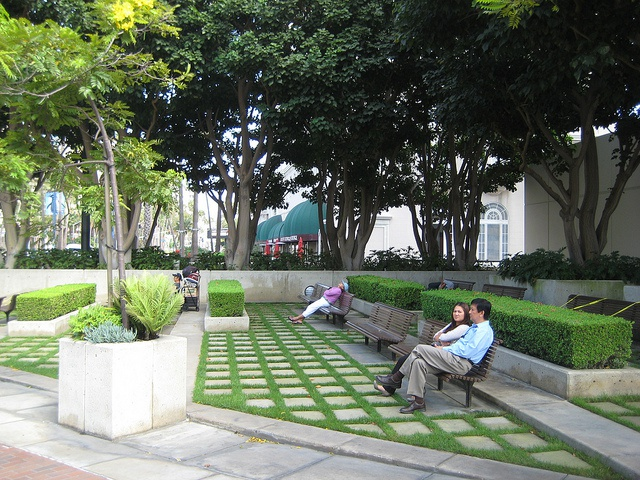Describe the objects in this image and their specific colors. I can see potted plant in black, white, khaki, lightgreen, and olive tones, people in black, darkgray, gray, and lightblue tones, potted plant in black, darkgreen, and gray tones, bench in black and gray tones, and potted plant in black, darkgreen, lightgray, lightgreen, and olive tones in this image. 